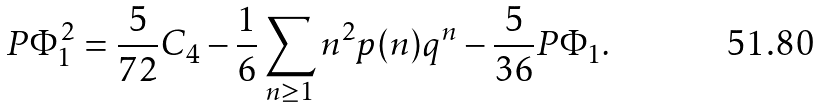<formula> <loc_0><loc_0><loc_500><loc_500>P \Phi _ { 1 } ^ { 2 } = \frac { 5 } { 7 2 } C _ { 4 } - \frac { 1 } { 6 } \sum _ { n \geq 1 } n ^ { 2 } p ( n ) q ^ { n } - \frac { 5 } { 3 6 } P \Phi _ { 1 } .</formula> 